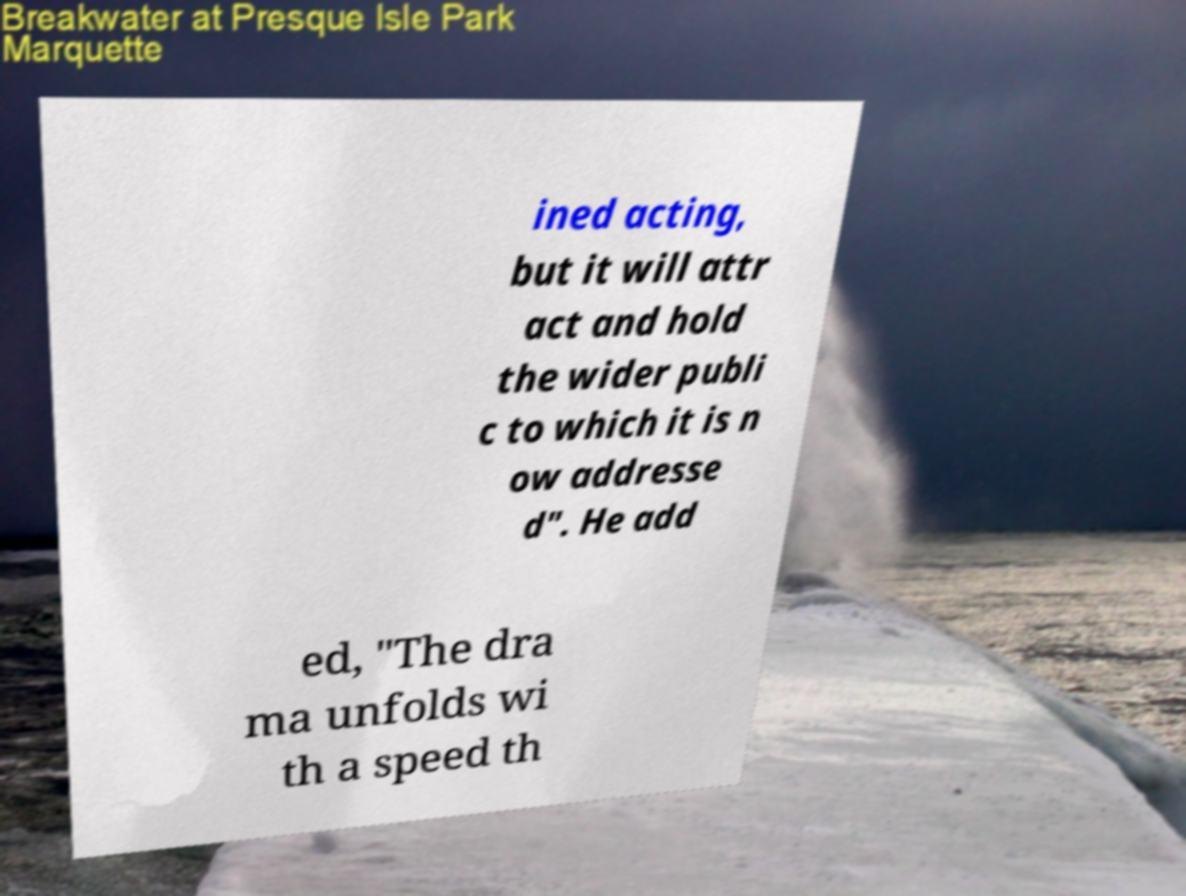There's text embedded in this image that I need extracted. Can you transcribe it verbatim? ined acting, but it will attr act and hold the wider publi c to which it is n ow addresse d". He add ed, "The dra ma unfolds wi th a speed th 